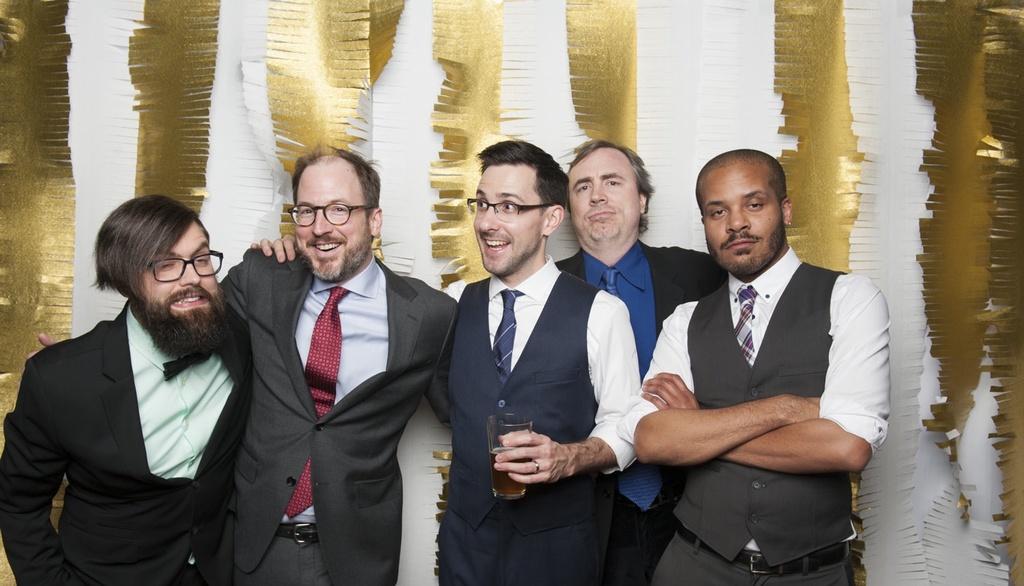Can you describe this image briefly? In the background we can see decoration with golden and white papers. We can see man standing. Among them three are wearing spectacles and a man in the middle kids holding a glass with drink in his hand. 